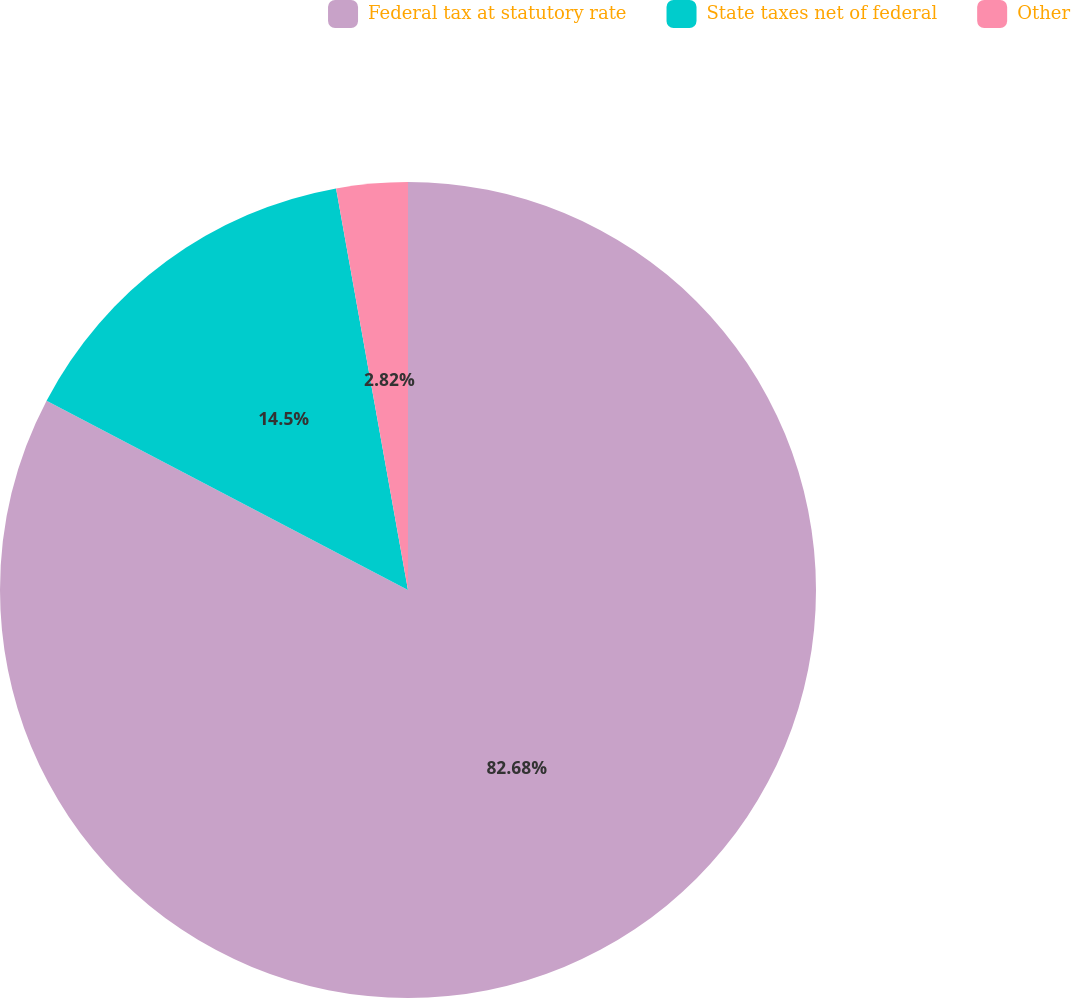Convert chart. <chart><loc_0><loc_0><loc_500><loc_500><pie_chart><fcel>Federal tax at statutory rate<fcel>State taxes net of federal<fcel>Other<nl><fcel>82.68%<fcel>14.5%<fcel>2.82%<nl></chart> 